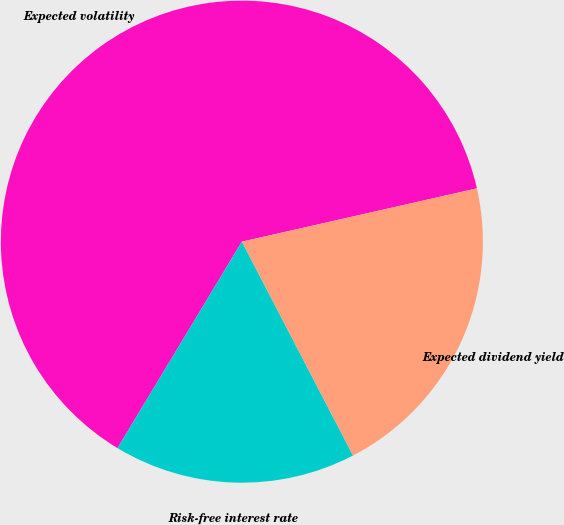Convert chart. <chart><loc_0><loc_0><loc_500><loc_500><pie_chart><fcel>Expected volatility<fcel>Risk-free interest rate<fcel>Expected dividend yield<nl><fcel>62.82%<fcel>16.26%<fcel>20.92%<nl></chart> 